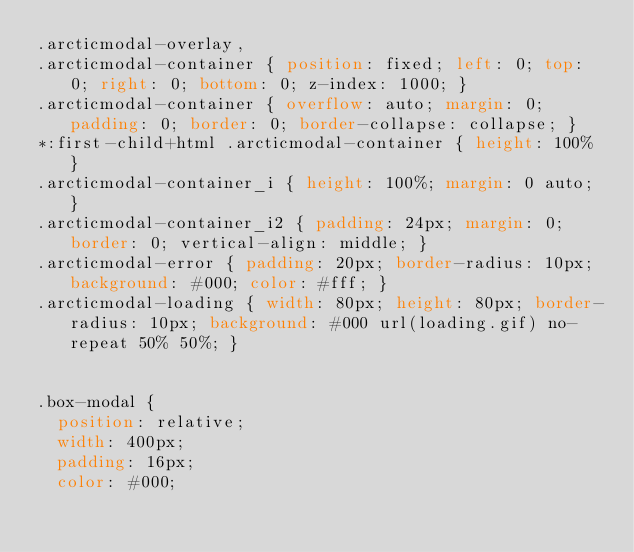Convert code to text. <code><loc_0><loc_0><loc_500><loc_500><_CSS_>.arcticmodal-overlay,
.arcticmodal-container { position: fixed; left: 0; top: 0; right: 0; bottom: 0; z-index: 1000; }
.arcticmodal-container { overflow: auto; margin: 0; padding: 0; border: 0; border-collapse: collapse; }
*:first-child+html .arcticmodal-container { height: 100% }
.arcticmodal-container_i { height: 100%; margin: 0 auto; }
.arcticmodal-container_i2 { padding: 24px; margin: 0; border: 0; vertical-align: middle; }
.arcticmodal-error { padding: 20px; border-radius: 10px; background: #000; color: #fff; }
.arcticmodal-loading { width: 80px; height: 80px; border-radius: 10px; background: #000 url(loading.gif) no-repeat 50% 50%; }


.box-modal {
	position: relative;
	width: 400px;
	padding: 16px; 
	color: #000;</code> 